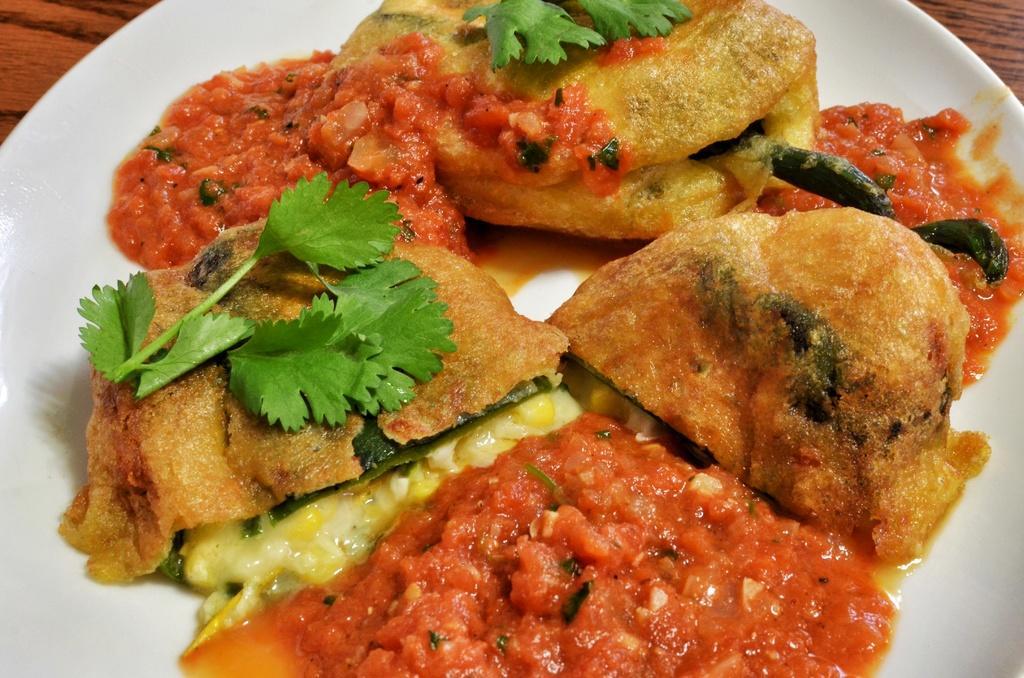Can you describe this image briefly? In this image, we can see food on the white plate. On the right side and left side corner of the image, we can see the wooden surface. 